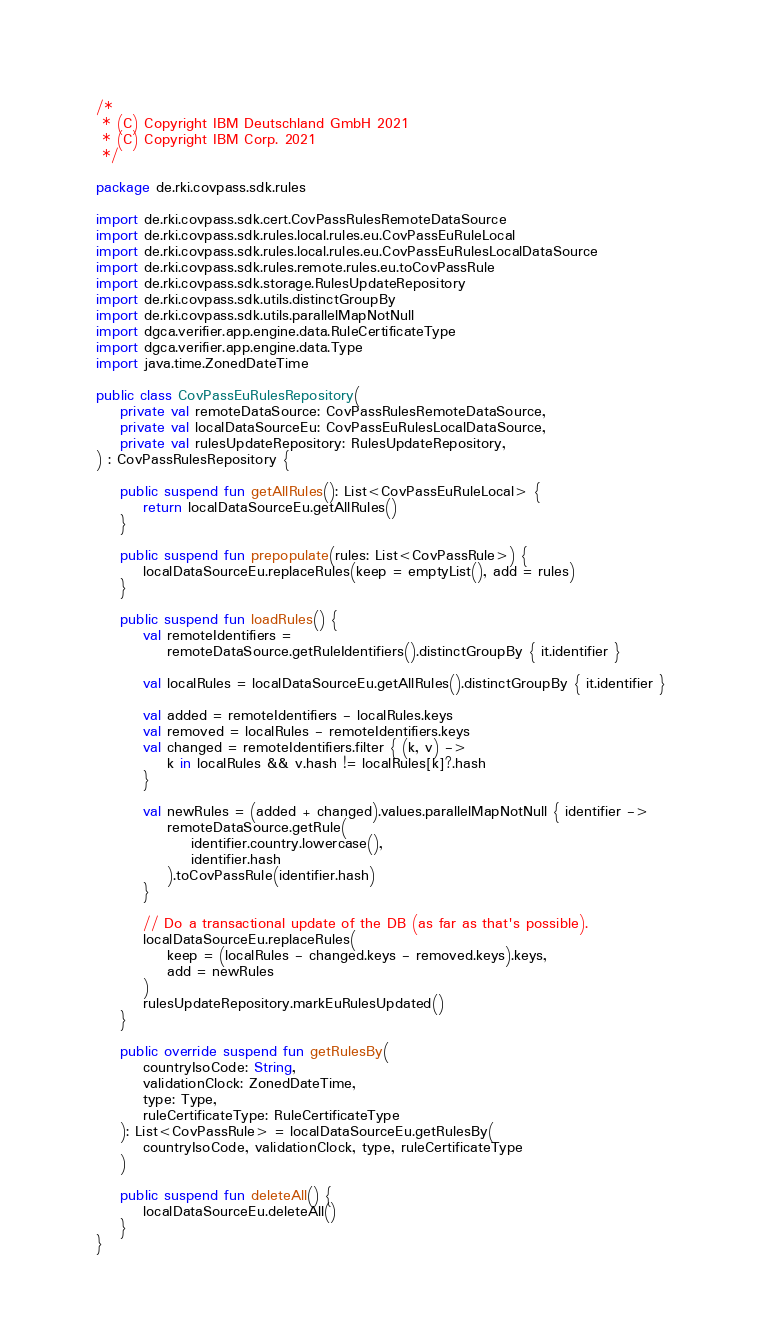Convert code to text. <code><loc_0><loc_0><loc_500><loc_500><_Kotlin_>/*
 * (C) Copyright IBM Deutschland GmbH 2021
 * (C) Copyright IBM Corp. 2021
 */

package de.rki.covpass.sdk.rules

import de.rki.covpass.sdk.cert.CovPassRulesRemoteDataSource
import de.rki.covpass.sdk.rules.local.rules.eu.CovPassEuRuleLocal
import de.rki.covpass.sdk.rules.local.rules.eu.CovPassEuRulesLocalDataSource
import de.rki.covpass.sdk.rules.remote.rules.eu.toCovPassRule
import de.rki.covpass.sdk.storage.RulesUpdateRepository
import de.rki.covpass.sdk.utils.distinctGroupBy
import de.rki.covpass.sdk.utils.parallelMapNotNull
import dgca.verifier.app.engine.data.RuleCertificateType
import dgca.verifier.app.engine.data.Type
import java.time.ZonedDateTime

public class CovPassEuRulesRepository(
    private val remoteDataSource: CovPassRulesRemoteDataSource,
    private val localDataSourceEu: CovPassEuRulesLocalDataSource,
    private val rulesUpdateRepository: RulesUpdateRepository,
) : CovPassRulesRepository {

    public suspend fun getAllRules(): List<CovPassEuRuleLocal> {
        return localDataSourceEu.getAllRules()
    }

    public suspend fun prepopulate(rules: List<CovPassRule>) {
        localDataSourceEu.replaceRules(keep = emptyList(), add = rules)
    }

    public suspend fun loadRules() {
        val remoteIdentifiers =
            remoteDataSource.getRuleIdentifiers().distinctGroupBy { it.identifier }

        val localRules = localDataSourceEu.getAllRules().distinctGroupBy { it.identifier }

        val added = remoteIdentifiers - localRules.keys
        val removed = localRules - remoteIdentifiers.keys
        val changed = remoteIdentifiers.filter { (k, v) ->
            k in localRules && v.hash != localRules[k]?.hash
        }

        val newRules = (added + changed).values.parallelMapNotNull { identifier ->
            remoteDataSource.getRule(
                identifier.country.lowercase(),
                identifier.hash
            ).toCovPassRule(identifier.hash)
        }

        // Do a transactional update of the DB (as far as that's possible).
        localDataSourceEu.replaceRules(
            keep = (localRules - changed.keys - removed.keys).keys,
            add = newRules
        )
        rulesUpdateRepository.markEuRulesUpdated()
    }

    public override suspend fun getRulesBy(
        countryIsoCode: String,
        validationClock: ZonedDateTime,
        type: Type,
        ruleCertificateType: RuleCertificateType
    ): List<CovPassRule> = localDataSourceEu.getRulesBy(
        countryIsoCode, validationClock, type, ruleCertificateType
    )

    public suspend fun deleteAll() {
        localDataSourceEu.deleteAll()
    }
}
</code> 